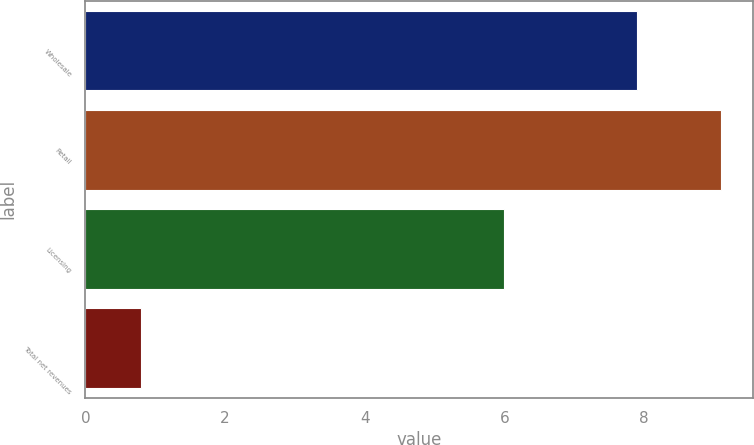<chart> <loc_0><loc_0><loc_500><loc_500><bar_chart><fcel>Wholesale<fcel>Retail<fcel>Licensing<fcel>Total net revenues<nl><fcel>7.9<fcel>9.1<fcel>6<fcel>0.8<nl></chart> 